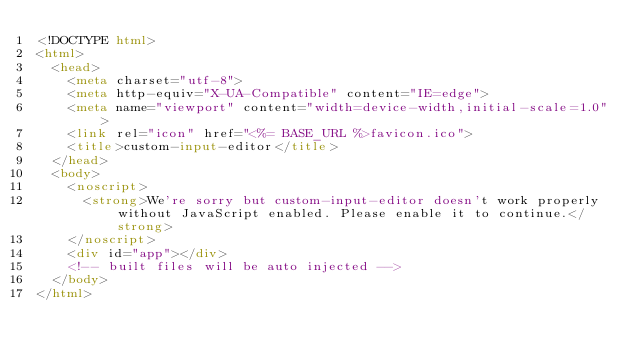Convert code to text. <code><loc_0><loc_0><loc_500><loc_500><_HTML_><!DOCTYPE html>
<html>
  <head>
    <meta charset="utf-8">
    <meta http-equiv="X-UA-Compatible" content="IE=edge">
    <meta name="viewport" content="width=device-width,initial-scale=1.0">
    <link rel="icon" href="<%= BASE_URL %>favicon.ico">
    <title>custom-input-editor</title>
  </head>
  <body>
    <noscript>
      <strong>We're sorry but custom-input-editor doesn't work properly without JavaScript enabled. Please enable it to continue.</strong>
    </noscript>
    <div id="app"></div>
    <!-- built files will be auto injected -->
  </body>
</html>
</code> 